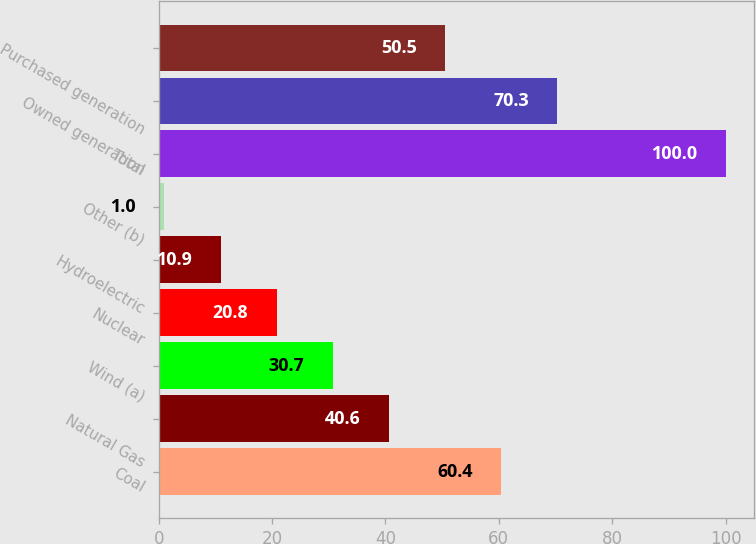Convert chart to OTSL. <chart><loc_0><loc_0><loc_500><loc_500><bar_chart><fcel>Coal<fcel>Natural Gas<fcel>Wind (a)<fcel>Nuclear<fcel>Hydroelectric<fcel>Other (b)<fcel>Total<fcel>Owned generation<fcel>Purchased generation<nl><fcel>60.4<fcel>40.6<fcel>30.7<fcel>20.8<fcel>10.9<fcel>1<fcel>100<fcel>70.3<fcel>50.5<nl></chart> 